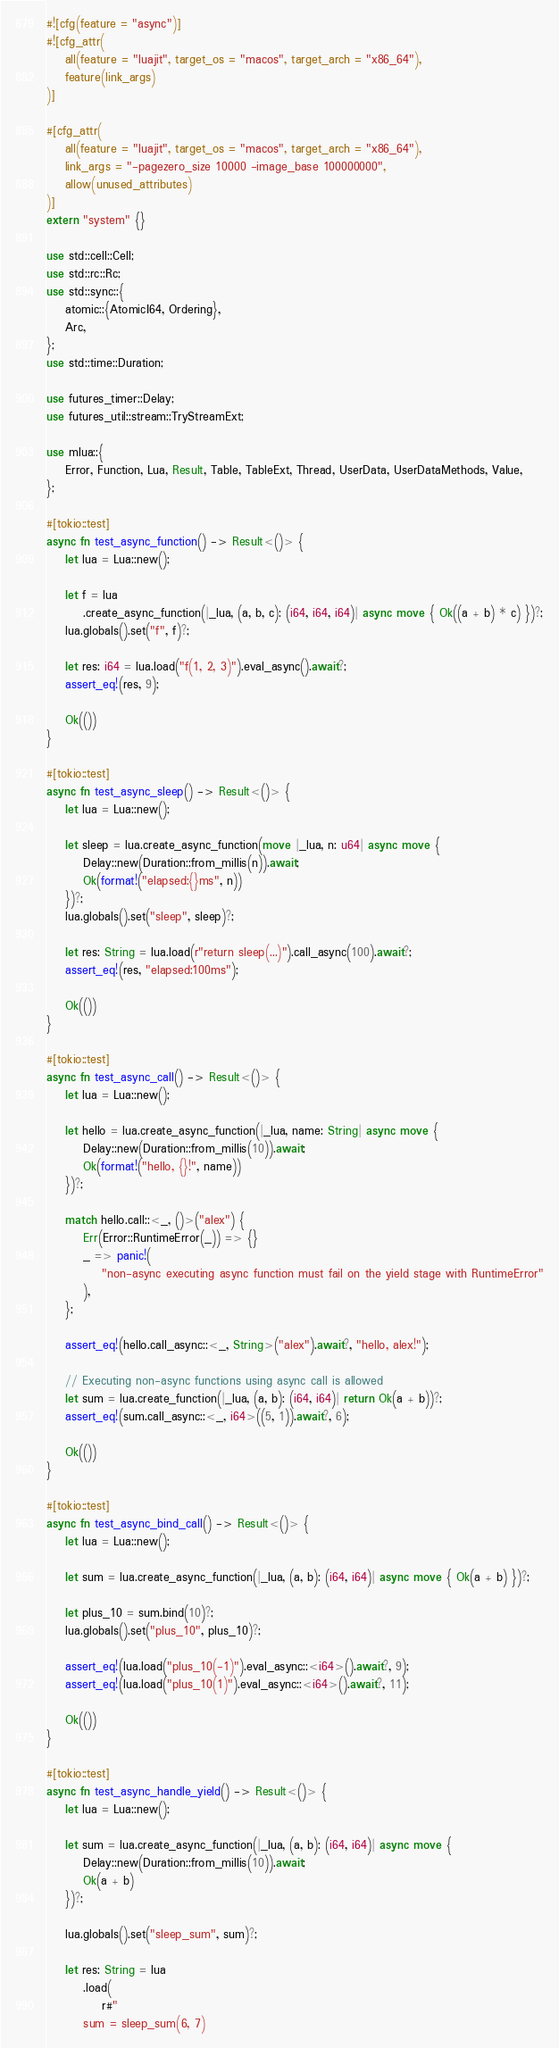<code> <loc_0><loc_0><loc_500><loc_500><_Rust_>#![cfg(feature = "async")]
#![cfg_attr(
    all(feature = "luajit", target_os = "macos", target_arch = "x86_64"),
    feature(link_args)
)]

#[cfg_attr(
    all(feature = "luajit", target_os = "macos", target_arch = "x86_64"),
    link_args = "-pagezero_size 10000 -image_base 100000000",
    allow(unused_attributes)
)]
extern "system" {}

use std::cell::Cell;
use std::rc::Rc;
use std::sync::{
    atomic::{AtomicI64, Ordering},
    Arc,
};
use std::time::Duration;

use futures_timer::Delay;
use futures_util::stream::TryStreamExt;

use mlua::{
    Error, Function, Lua, Result, Table, TableExt, Thread, UserData, UserDataMethods, Value,
};

#[tokio::test]
async fn test_async_function() -> Result<()> {
    let lua = Lua::new();

    let f = lua
        .create_async_function(|_lua, (a, b, c): (i64, i64, i64)| async move { Ok((a + b) * c) })?;
    lua.globals().set("f", f)?;

    let res: i64 = lua.load("f(1, 2, 3)").eval_async().await?;
    assert_eq!(res, 9);

    Ok(())
}

#[tokio::test]
async fn test_async_sleep() -> Result<()> {
    let lua = Lua::new();

    let sleep = lua.create_async_function(move |_lua, n: u64| async move {
        Delay::new(Duration::from_millis(n)).await;
        Ok(format!("elapsed:{}ms", n))
    })?;
    lua.globals().set("sleep", sleep)?;

    let res: String = lua.load(r"return sleep(...)").call_async(100).await?;
    assert_eq!(res, "elapsed:100ms");

    Ok(())
}

#[tokio::test]
async fn test_async_call() -> Result<()> {
    let lua = Lua::new();

    let hello = lua.create_async_function(|_lua, name: String| async move {
        Delay::new(Duration::from_millis(10)).await;
        Ok(format!("hello, {}!", name))
    })?;

    match hello.call::<_, ()>("alex") {
        Err(Error::RuntimeError(_)) => {}
        _ => panic!(
            "non-async executing async function must fail on the yield stage with RuntimeError"
        ),
    };

    assert_eq!(hello.call_async::<_, String>("alex").await?, "hello, alex!");

    // Executing non-async functions using async call is allowed
    let sum = lua.create_function(|_lua, (a, b): (i64, i64)| return Ok(a + b))?;
    assert_eq!(sum.call_async::<_, i64>((5, 1)).await?, 6);

    Ok(())
}

#[tokio::test]
async fn test_async_bind_call() -> Result<()> {
    let lua = Lua::new();

    let sum = lua.create_async_function(|_lua, (a, b): (i64, i64)| async move { Ok(a + b) })?;

    let plus_10 = sum.bind(10)?;
    lua.globals().set("plus_10", plus_10)?;

    assert_eq!(lua.load("plus_10(-1)").eval_async::<i64>().await?, 9);
    assert_eq!(lua.load("plus_10(1)").eval_async::<i64>().await?, 11);

    Ok(())
}

#[tokio::test]
async fn test_async_handle_yield() -> Result<()> {
    let lua = Lua::new();

    let sum = lua.create_async_function(|_lua, (a, b): (i64, i64)| async move {
        Delay::new(Duration::from_millis(10)).await;
        Ok(a + b)
    })?;

    lua.globals().set("sleep_sum", sum)?;

    let res: String = lua
        .load(
            r#"
        sum = sleep_sum(6, 7)</code> 